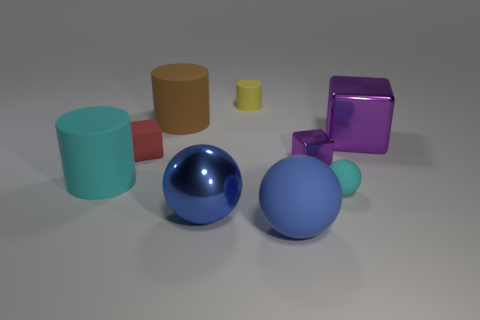What material is the small thing that is to the left of the small rubber sphere and on the right side of the tiny rubber cylinder?
Your answer should be compact. Metal. Does the cyan object that is on the left side of the yellow rubber cylinder have the same size as the small cylinder?
Provide a succinct answer. No. Is the number of large cylinders in front of the big brown thing greater than the number of small objects in front of the large blue matte sphere?
Offer a terse response. Yes. What is the color of the object that is in front of the blue object that is on the left side of the matte cylinder that is behind the big brown cylinder?
Your answer should be compact. Blue. There is a shiny block behind the tiny purple metal thing; is it the same color as the small shiny block?
Your answer should be compact. Yes. How many other things are there of the same color as the tiny rubber cube?
Make the answer very short. 0. What number of things are cyan rubber cylinders or metallic balls?
Provide a short and direct response. 2. What number of things are either gray rubber balls or purple cubes that are to the left of the big purple block?
Your response must be concise. 1. Is the small purple cube made of the same material as the tiny cyan object?
Provide a succinct answer. No. What number of other things are made of the same material as the yellow thing?
Ensure brevity in your answer.  5. 